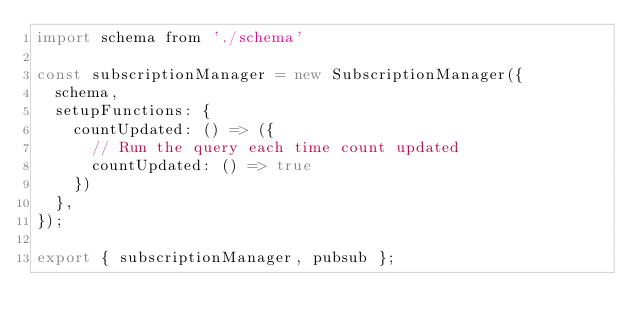<code> <loc_0><loc_0><loc_500><loc_500><_JavaScript_>import schema from './schema'

const subscriptionManager = new SubscriptionManager({
  schema,
  setupFunctions: {
    countUpdated: () => ({
      // Run the query each time count updated
      countUpdated: () => true
    })
  },
});

export { subscriptionManager, pubsub };</code> 